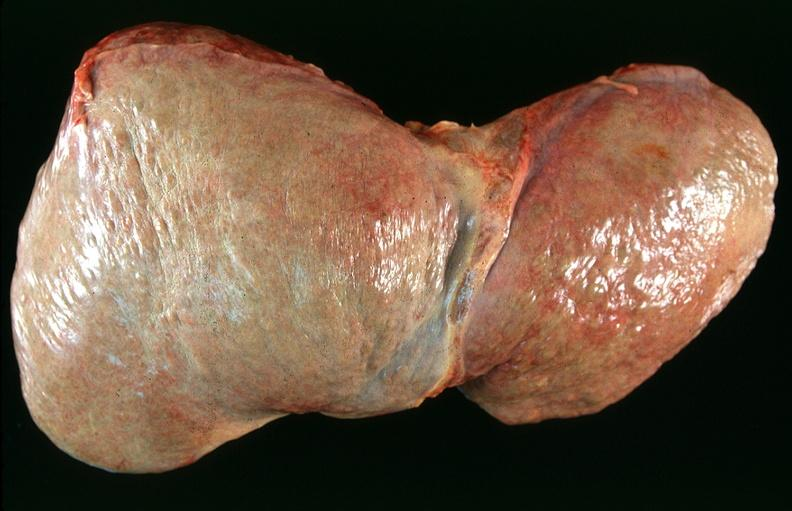how many antitrypsin does this image show liver, cirrhosis alpha-deficiency?
Answer the question using a single word or phrase. 1 